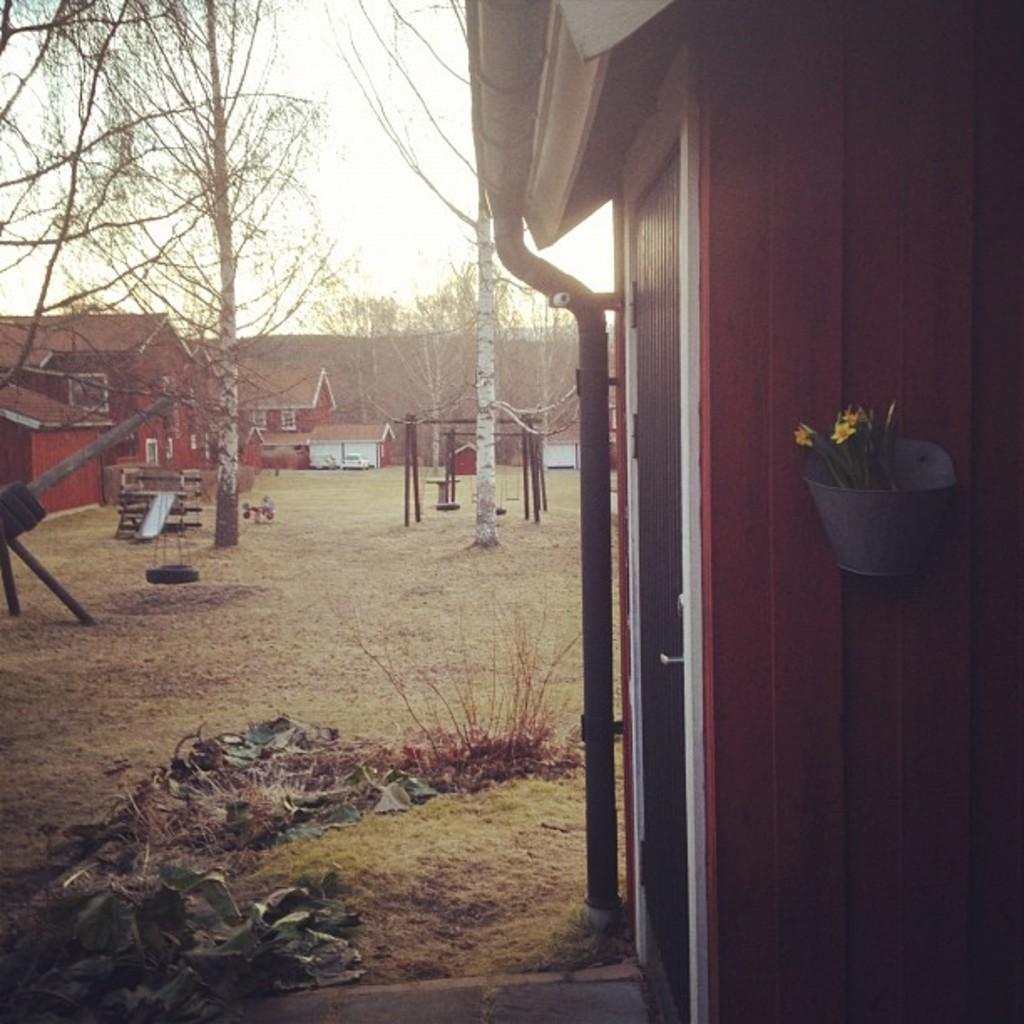Describe this image in one or two sentences. In this image there are houses, plant, grass, trees, skyslide and objects. 